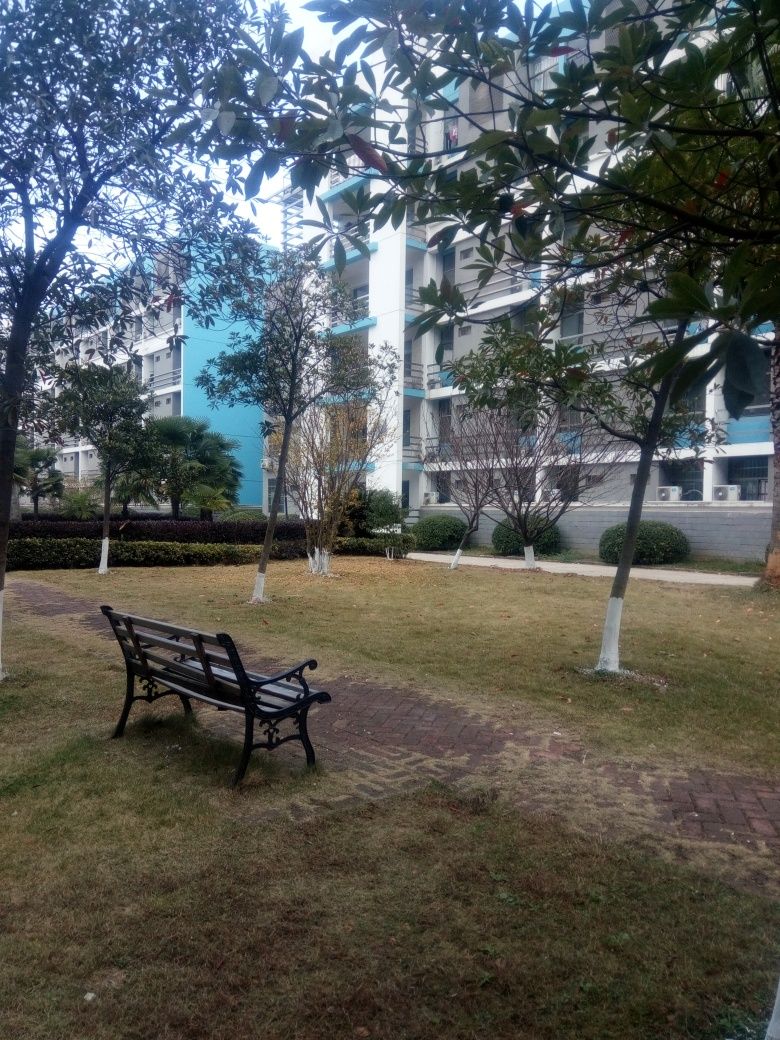Can you describe the weather or atmosphere based on the image? The weather appears to be overcast, with a cloudy sky suggesting that it might be a cool or temperate day. The lack of shadows on the ground indicates that the sun is not out at full strength. The atmosphere seems calm and serene, with an empty bench hinting at a tranquil moment in a possibly urban setting. 